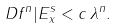<formula> <loc_0><loc_0><loc_500><loc_500>\| D f ^ { n } | E ^ { s } _ { x } \| < c \, \lambda ^ { n } .</formula> 